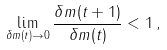Convert formula to latex. <formula><loc_0><loc_0><loc_500><loc_500>\lim _ { { \delta } m ( t ) \rightarrow 0 } \frac { { \delta } m ( t + 1 ) } { { \delta } m ( t ) } < 1 \, ,</formula> 